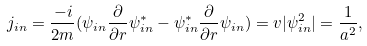Convert formula to latex. <formula><loc_0><loc_0><loc_500><loc_500>j _ { i n } = \frac { - i } { 2 m } ( \psi _ { i n } \frac { \partial } { \partial r } \psi _ { i n } ^ { * } - \psi _ { i n } ^ { * } \frac { \partial } { \partial r } \psi _ { i n } ) = v | \psi ^ { 2 } _ { i n } | = \frac { 1 } { a ^ { 2 } } ,</formula> 